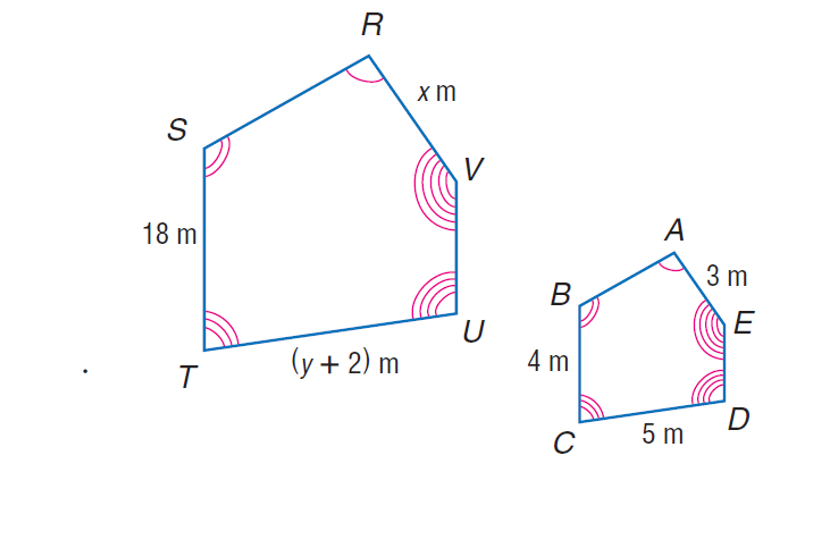Answer the mathemtical geometry problem and directly provide the correct option letter.
Question: The two polygons are similar. Then, find y.
Choices: A: 18 B: 20.5 C: 38 D: 199 B 